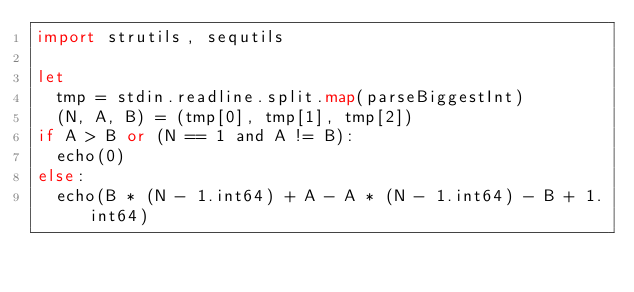Convert code to text. <code><loc_0><loc_0><loc_500><loc_500><_Nim_>import strutils, sequtils

let
  tmp = stdin.readline.split.map(parseBiggestInt)
  (N, A, B) = (tmp[0], tmp[1], tmp[2])
if A > B or (N == 1 and A != B):
  echo(0)
else:
  echo(B * (N - 1.int64) + A - A * (N - 1.int64) - B + 1.int64)
</code> 